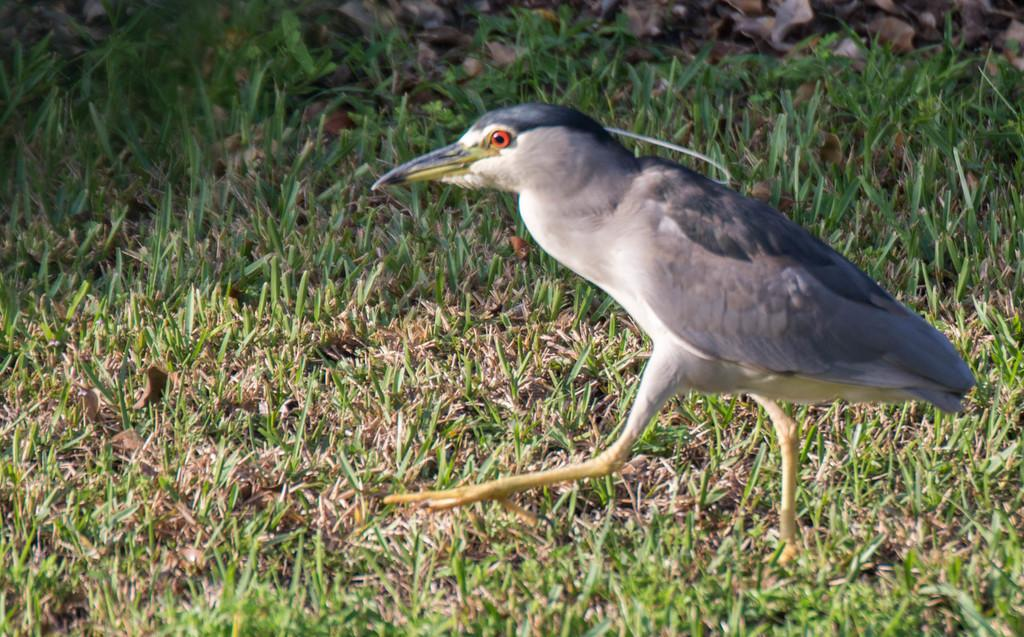What is the main subject of the image? There is a bird in the center of the image. Where is the bird located? The bird is on the grass. What type of credit card is the bird holding in the image? There is no credit card present in the image; it features a bird on the grass. Can you tell me how many airports are visible in the image? There are no airports visible in the image; it features a bird on the grass. 